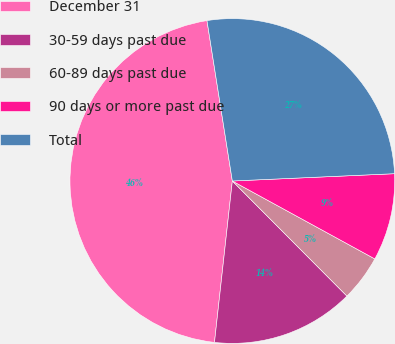Convert chart. <chart><loc_0><loc_0><loc_500><loc_500><pie_chart><fcel>December 31<fcel>30-59 days past due<fcel>60-89 days past due<fcel>90 days or more past due<fcel>Total<nl><fcel>45.75%<fcel>14.22%<fcel>4.57%<fcel>8.68%<fcel>26.78%<nl></chart> 